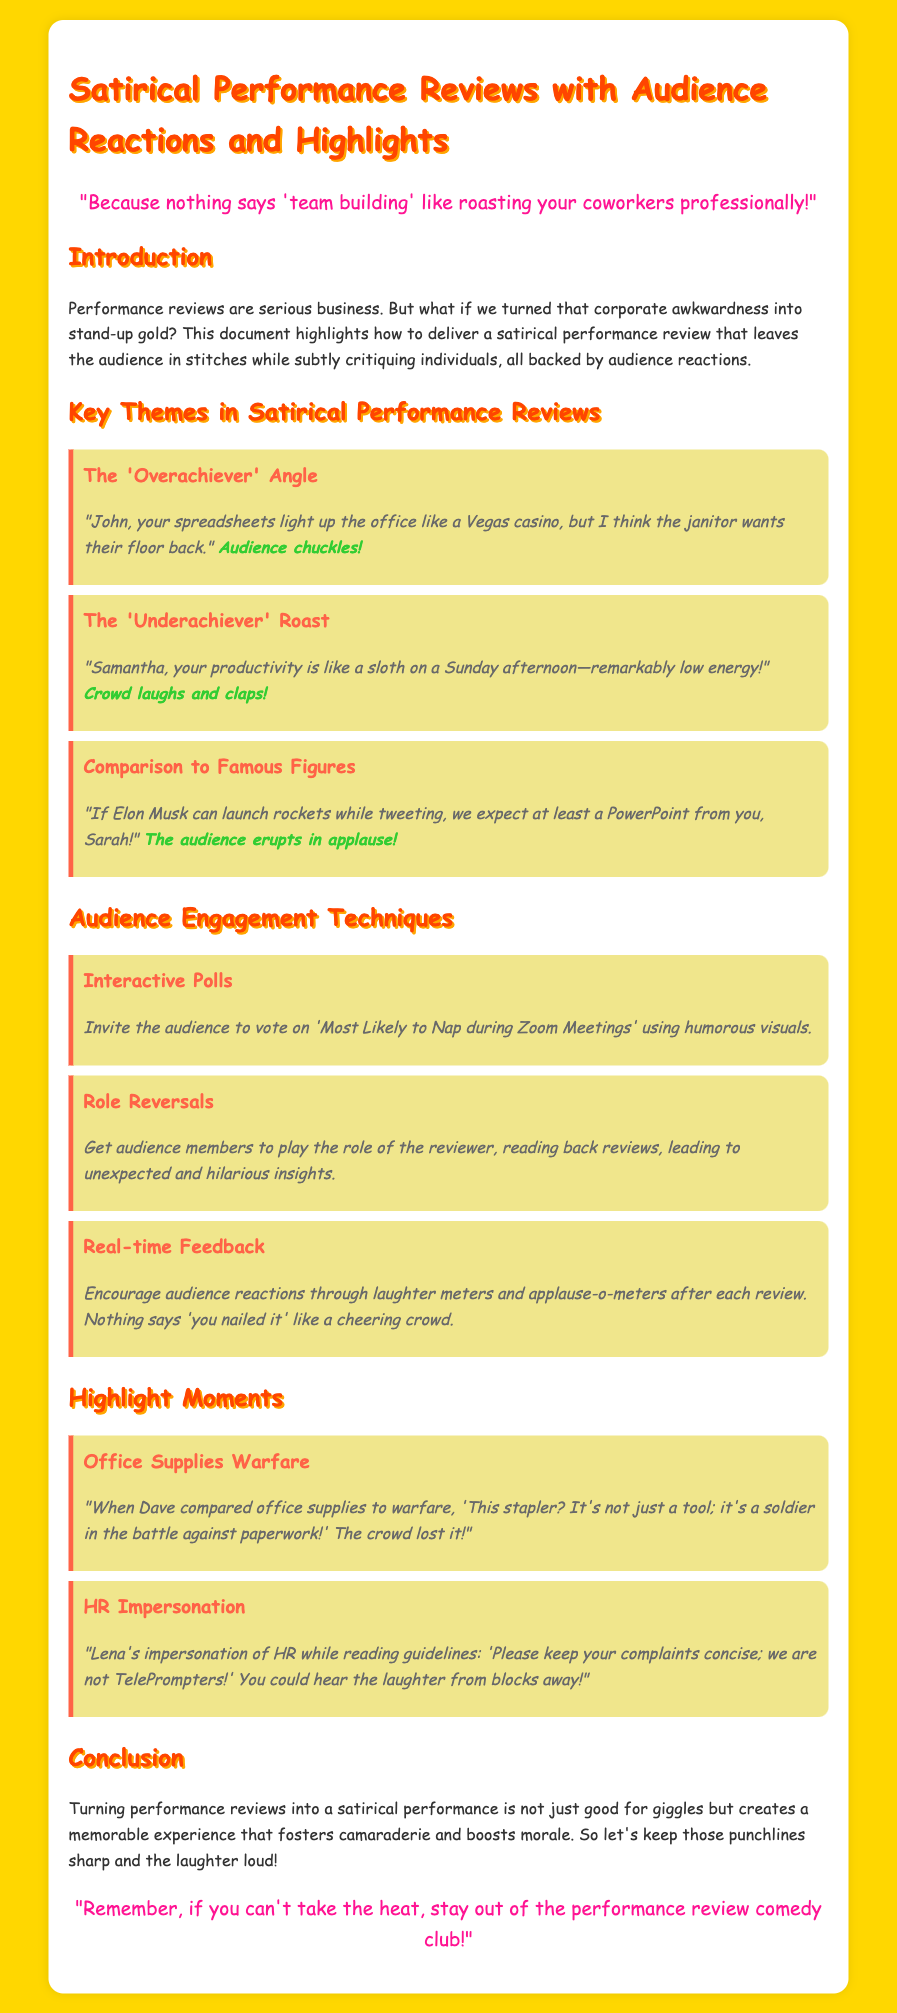What is the main theme of the document? The primary focus of the document is to present satirical performance reviews that combine humor with audience interaction.
Answer: satirical performance reviews Who is mentioned as an overachiever in the document? John is highlighted in the section examining the 'Overachiever' angle of satirical reviews.
Answer: John What phrase does the document use to describe Samantha's productivity? The performance review for Samantha humorously compares her productivity to a low-energy animal.
Answer: sloth on a Sunday afternoon What technique involves audience participation through voting? The document mentions a specific strategy that encourages audience engagement by voting on humorous categories.
Answer: Interactive Polls How did the audience react to Sarah's comparison to Elon Musk? The audience responded positively to the humorous comparison made during the performance review.
Answer: applause What is the tagline about taking the heat? The document provides witty taglines that connect comedy with the seriousness of performance reviews.
Answer: Remember, if you can't take the heat, stay out of the performance review comedy club! Which office supply was likened to a soldier in the document? Dave made a humorous analogy during the performance review regarding a common office item during his routine.
Answer: stapler What is the purpose of real-time feedback in the audience engagement techniques? Real-time feedback is suggested to enhance the performance review experience through audience enjoyment metrics.
Answer: cheering crowd 